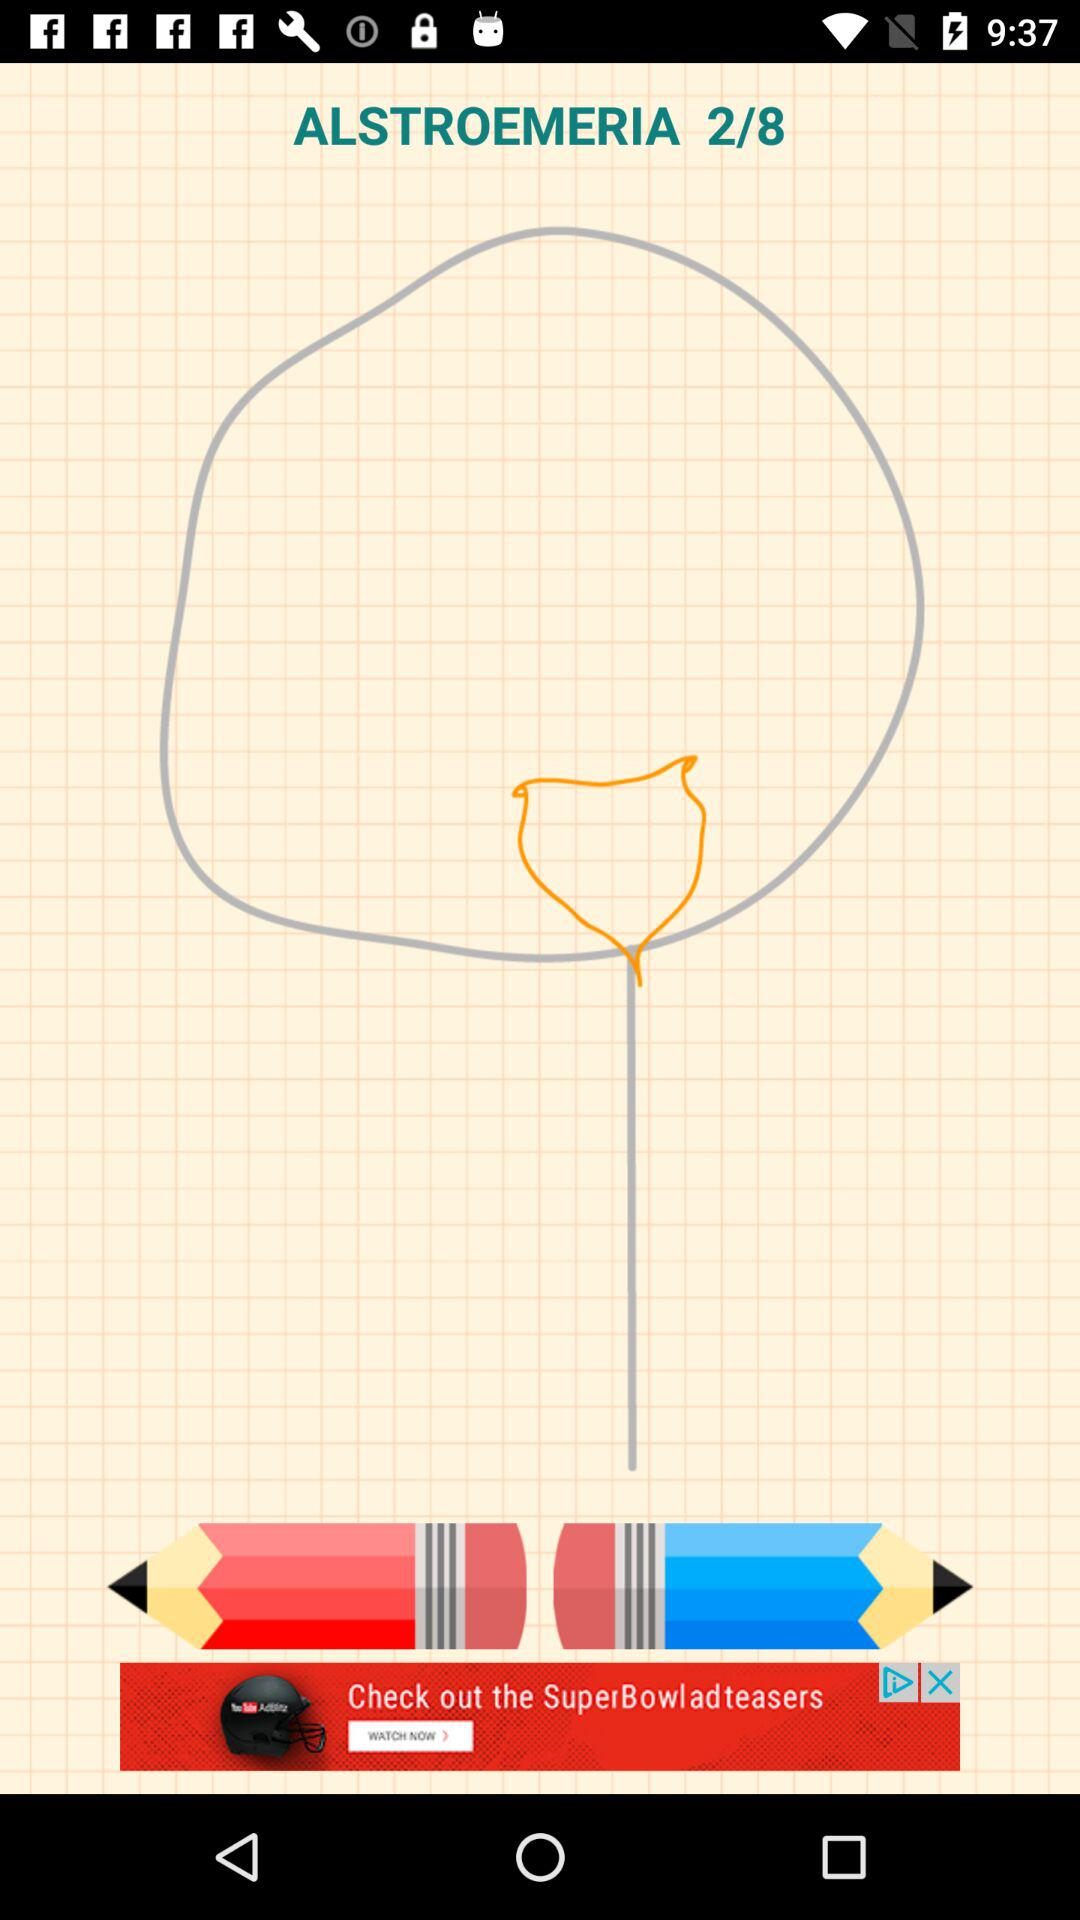What is the total number of alstroemeria? The total number of alstroemeria is 8. 